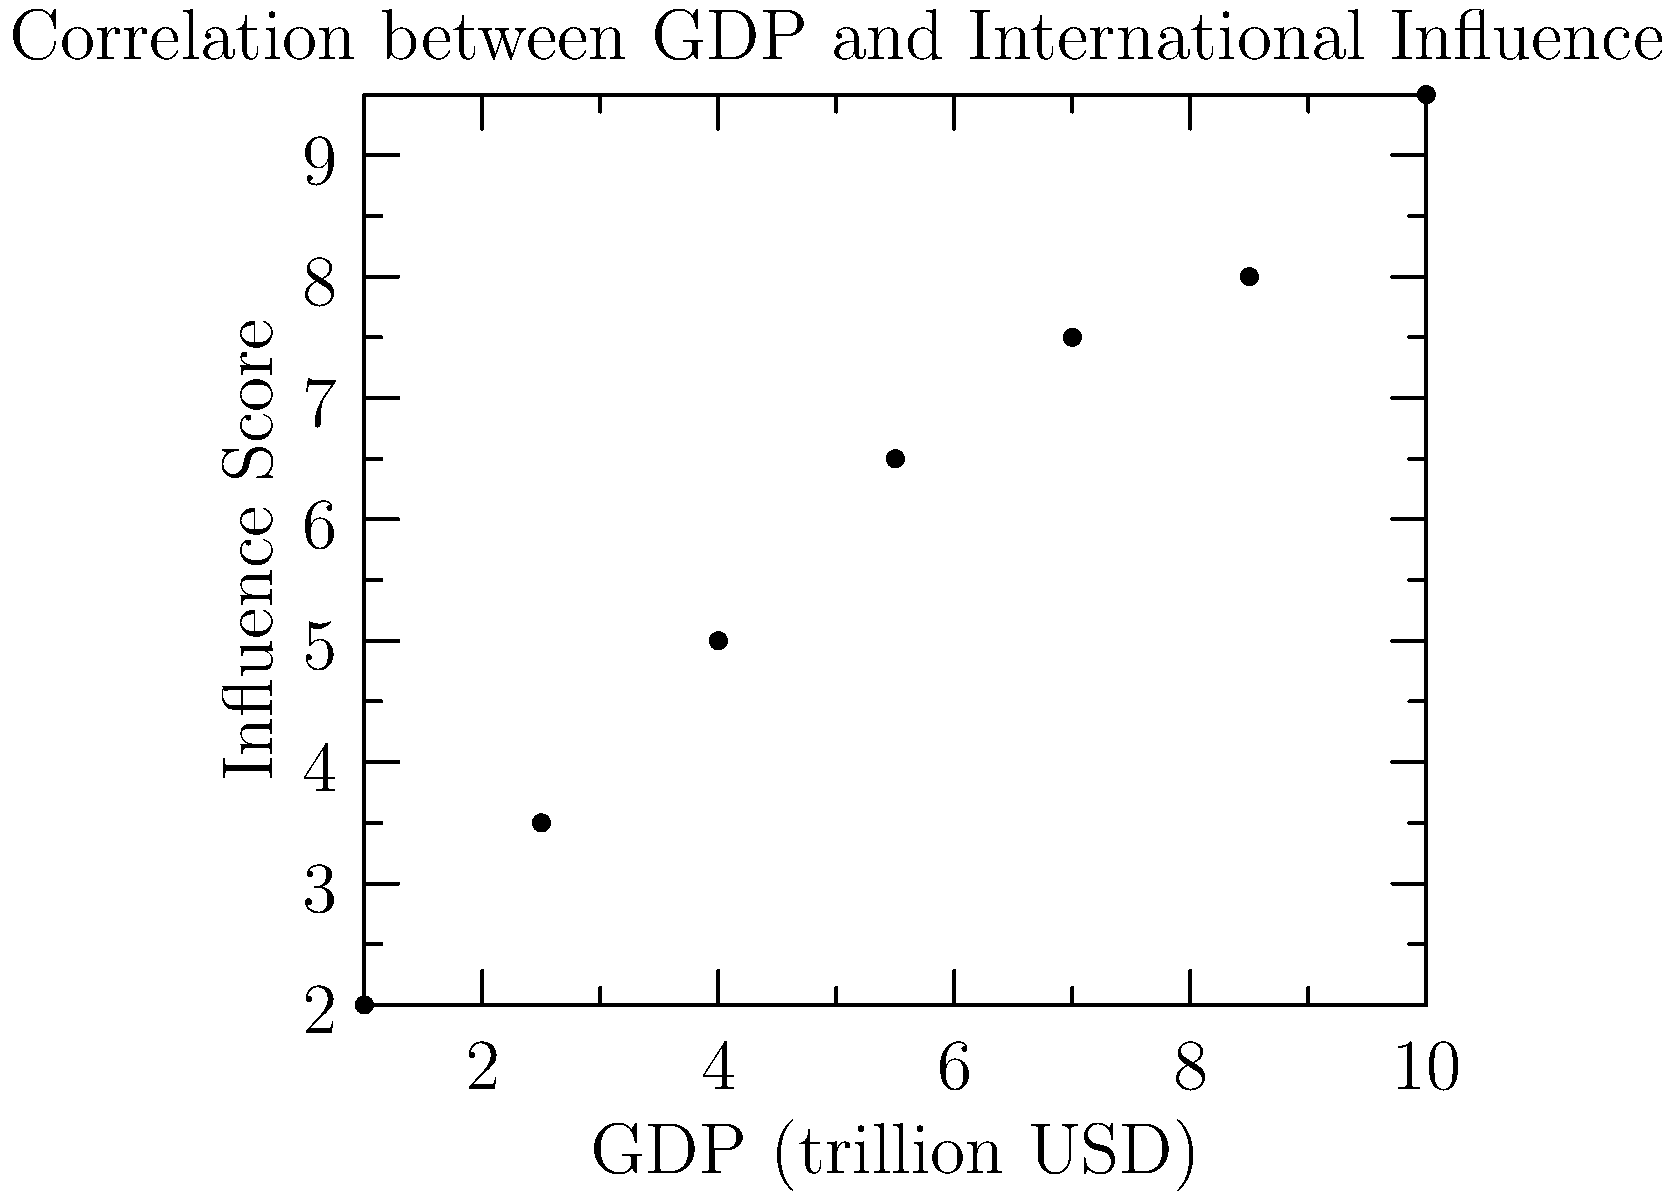As a former journalist transitioning to international relations, analyze the scatter plot showing the relationship between a country's GDP and its influence in international organizations. What type of correlation does this data suggest, and how might this inform policy decisions for countries seeking to increase their global influence? To analyze the correlation and its implications, let's follow these steps:

1. Observe the scatter plot:
   The points seem to follow an upward trend from left to right.

2. Identify the correlation type:
   As GDP increases, the influence score tends to increase as well. This suggests a positive correlation.

3. Assess the strength of the correlation:
   The points form a fairly tight pattern around an imaginary line, indicating a strong positive correlation.

4. Calculate the correlation coefficient (if given):
   In this case, we don't have the exact numbers, but visually, it appears to be close to 1, confirming a strong positive correlation.

5. Interpret the relationship:
   Countries with higher GDPs tend to have more influence in international organizations.

6. Consider policy implications:
   a) Countries aiming to increase their global influence might focus on economic growth strategies.
   b) Developing nations could argue for more representation in international bodies based on their growing economies.
   c) Economic diplomacy could be emphasized in foreign policy to boost both GDP and influence.

7. Journalistic perspective:
   This data could be used to investigate stories about economic power translating to political power on the global stage.

8. International relations angle:
   Understanding this correlation is crucial for analyzing power dynamics in global governance and predicting future shifts in international influence.
Answer: Strong positive correlation; countries should focus on economic growth to increase international influence. 